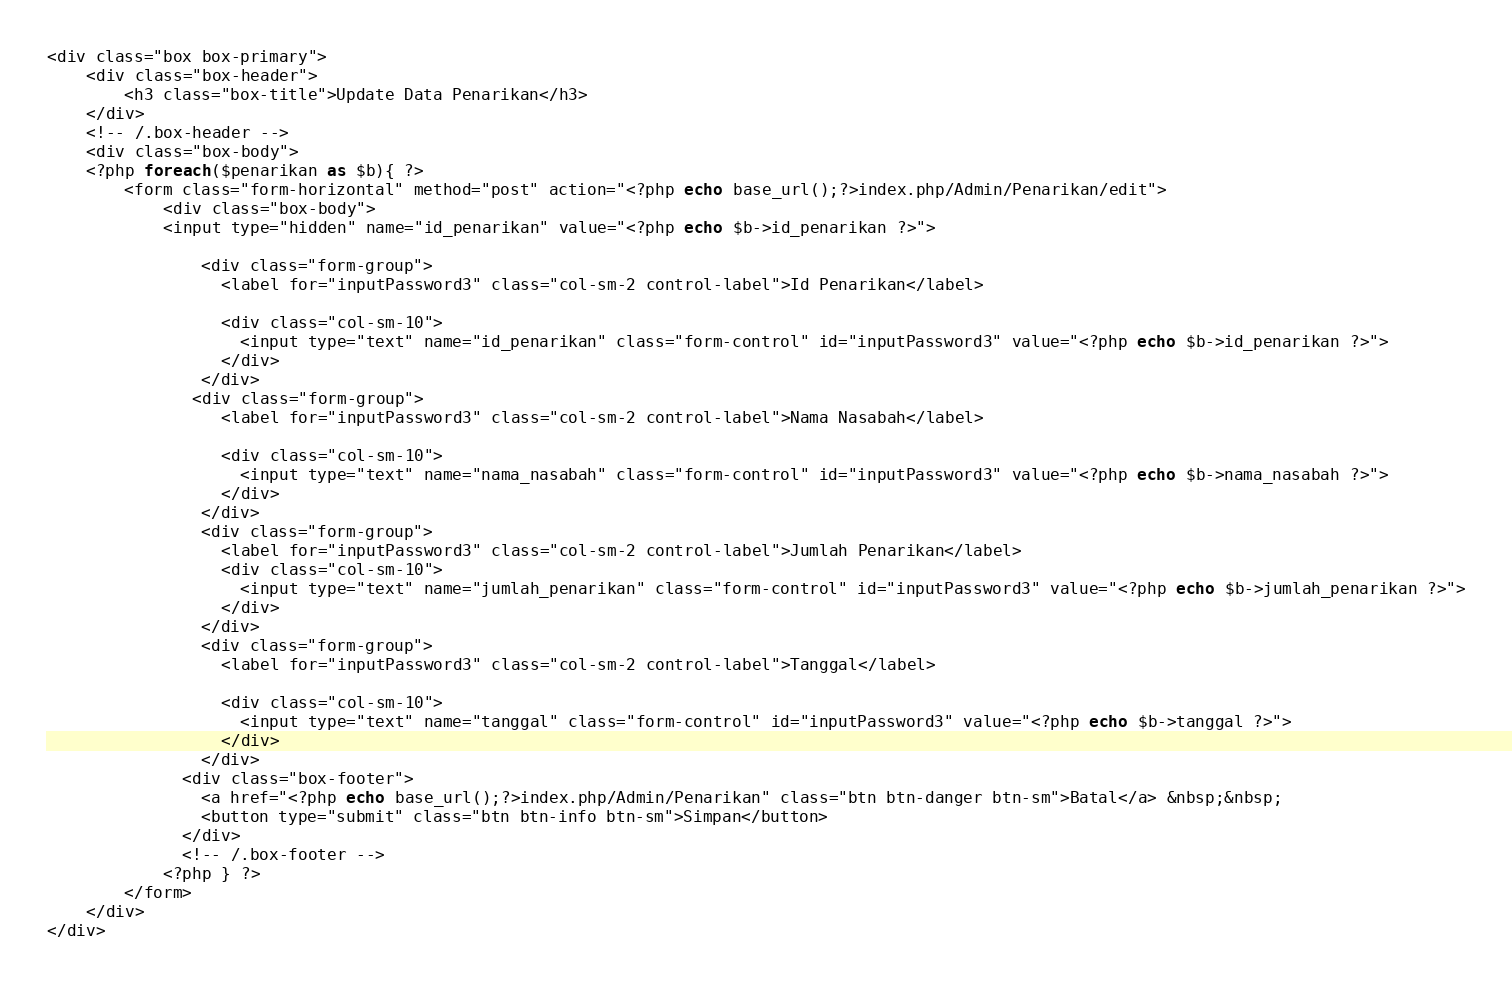<code> <loc_0><loc_0><loc_500><loc_500><_PHP_><div class="box box-primary">
	<div class="box-header">
        <h3 class="box-title">Update Data Penarikan</h3>
    </div>
    <!-- /.box-header -->
    <div class="box-body">
    <?php foreach($penarikan as $b){ ?>
		<form class="form-horizontal" method="post" action="<?php echo base_url();?>index.php/Admin/Penarikan/edit">
			<div class="box-body">
			<input type="hidden" name="id_penarikan" value="<?php echo $b->id_penarikan ?>">
      
                <div class="form-group">
                  <label for="inputPassword3" class="col-sm-2 control-label">Id Penarikan</label>

                  <div class="col-sm-10">
                    <input type="text" name="id_penarikan" class="form-control" id="inputPassword3" value="<?php echo $b->id_penarikan ?>">
                  </div>
                </div>
               <div class="form-group">
                  <label for="inputPassword3" class="col-sm-2 control-label">Nama Nasabah</label>

                  <div class="col-sm-10">
                    <input type="text" name="nama_nasabah" class="form-control" id="inputPassword3" value="<?php echo $b->nama_nasabah ?>">
                  </div>
                </div>
                <div class="form-group">
                  <label for="inputPassword3" class="col-sm-2 control-label">Jumlah Penarikan</label>
                  <div class="col-sm-10">
                    <input type="text" name="jumlah_penarikan" class="form-control" id="inputPassword3" value="<?php echo $b->jumlah_penarikan ?>">
                  </div>
                </div>
                <div class="form-group">
                  <label for="inputPassword3" class="col-sm-2 control-label">Tanggal</label>

                  <div class="col-sm-10">
                    <input type="text" name="tanggal" class="form-control" id="inputPassword3" value="<?php echo $b->tanggal ?>">
                  </div>
                </div>
              <div class="box-footer">
                <a href="<?php echo base_url();?>index.php/Admin/Penarikan" class="btn btn-danger btn-sm">Batal</a> &nbsp;&nbsp;
                <button type="submit" class="btn btn-info btn-sm">Simpan</button>
              </div>
              <!-- /.box-footer -->
            <?php } ?>
		</form>
	</div>
</div></code> 